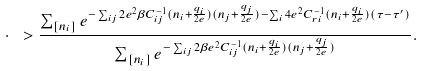Convert formula to latex. <formula><loc_0><loc_0><loc_500><loc_500>\cdot \ > \frac { \sum _ { [ n _ { i } ] } e ^ { - \sum _ { { i } { j } } 2 e ^ { 2 } \beta C _ { { i } { j } } ^ { - 1 } ( n _ { i } + \frac { q _ { i } } { 2 e } ) ( n _ { j } + \frac { q _ { j } } { 2 e } ) - \sum _ { i } 4 e ^ { 2 } C _ { { r } { i } } ^ { - 1 } ( n _ { i } + \frac { q _ { i } } { 2 e } ) ( \tau - \tau ^ { \prime } ) } } { \sum _ { [ n _ { i } ] } e ^ { - \sum _ { { i } { j } } 2 \beta e ^ { 2 } C _ { { i } { j } } ^ { - 1 } ( n _ { i } + \frac { q _ { i } } { 2 e } ) ( n _ { j } + \frac { q _ { j } } { 2 e } ) } } .</formula> 